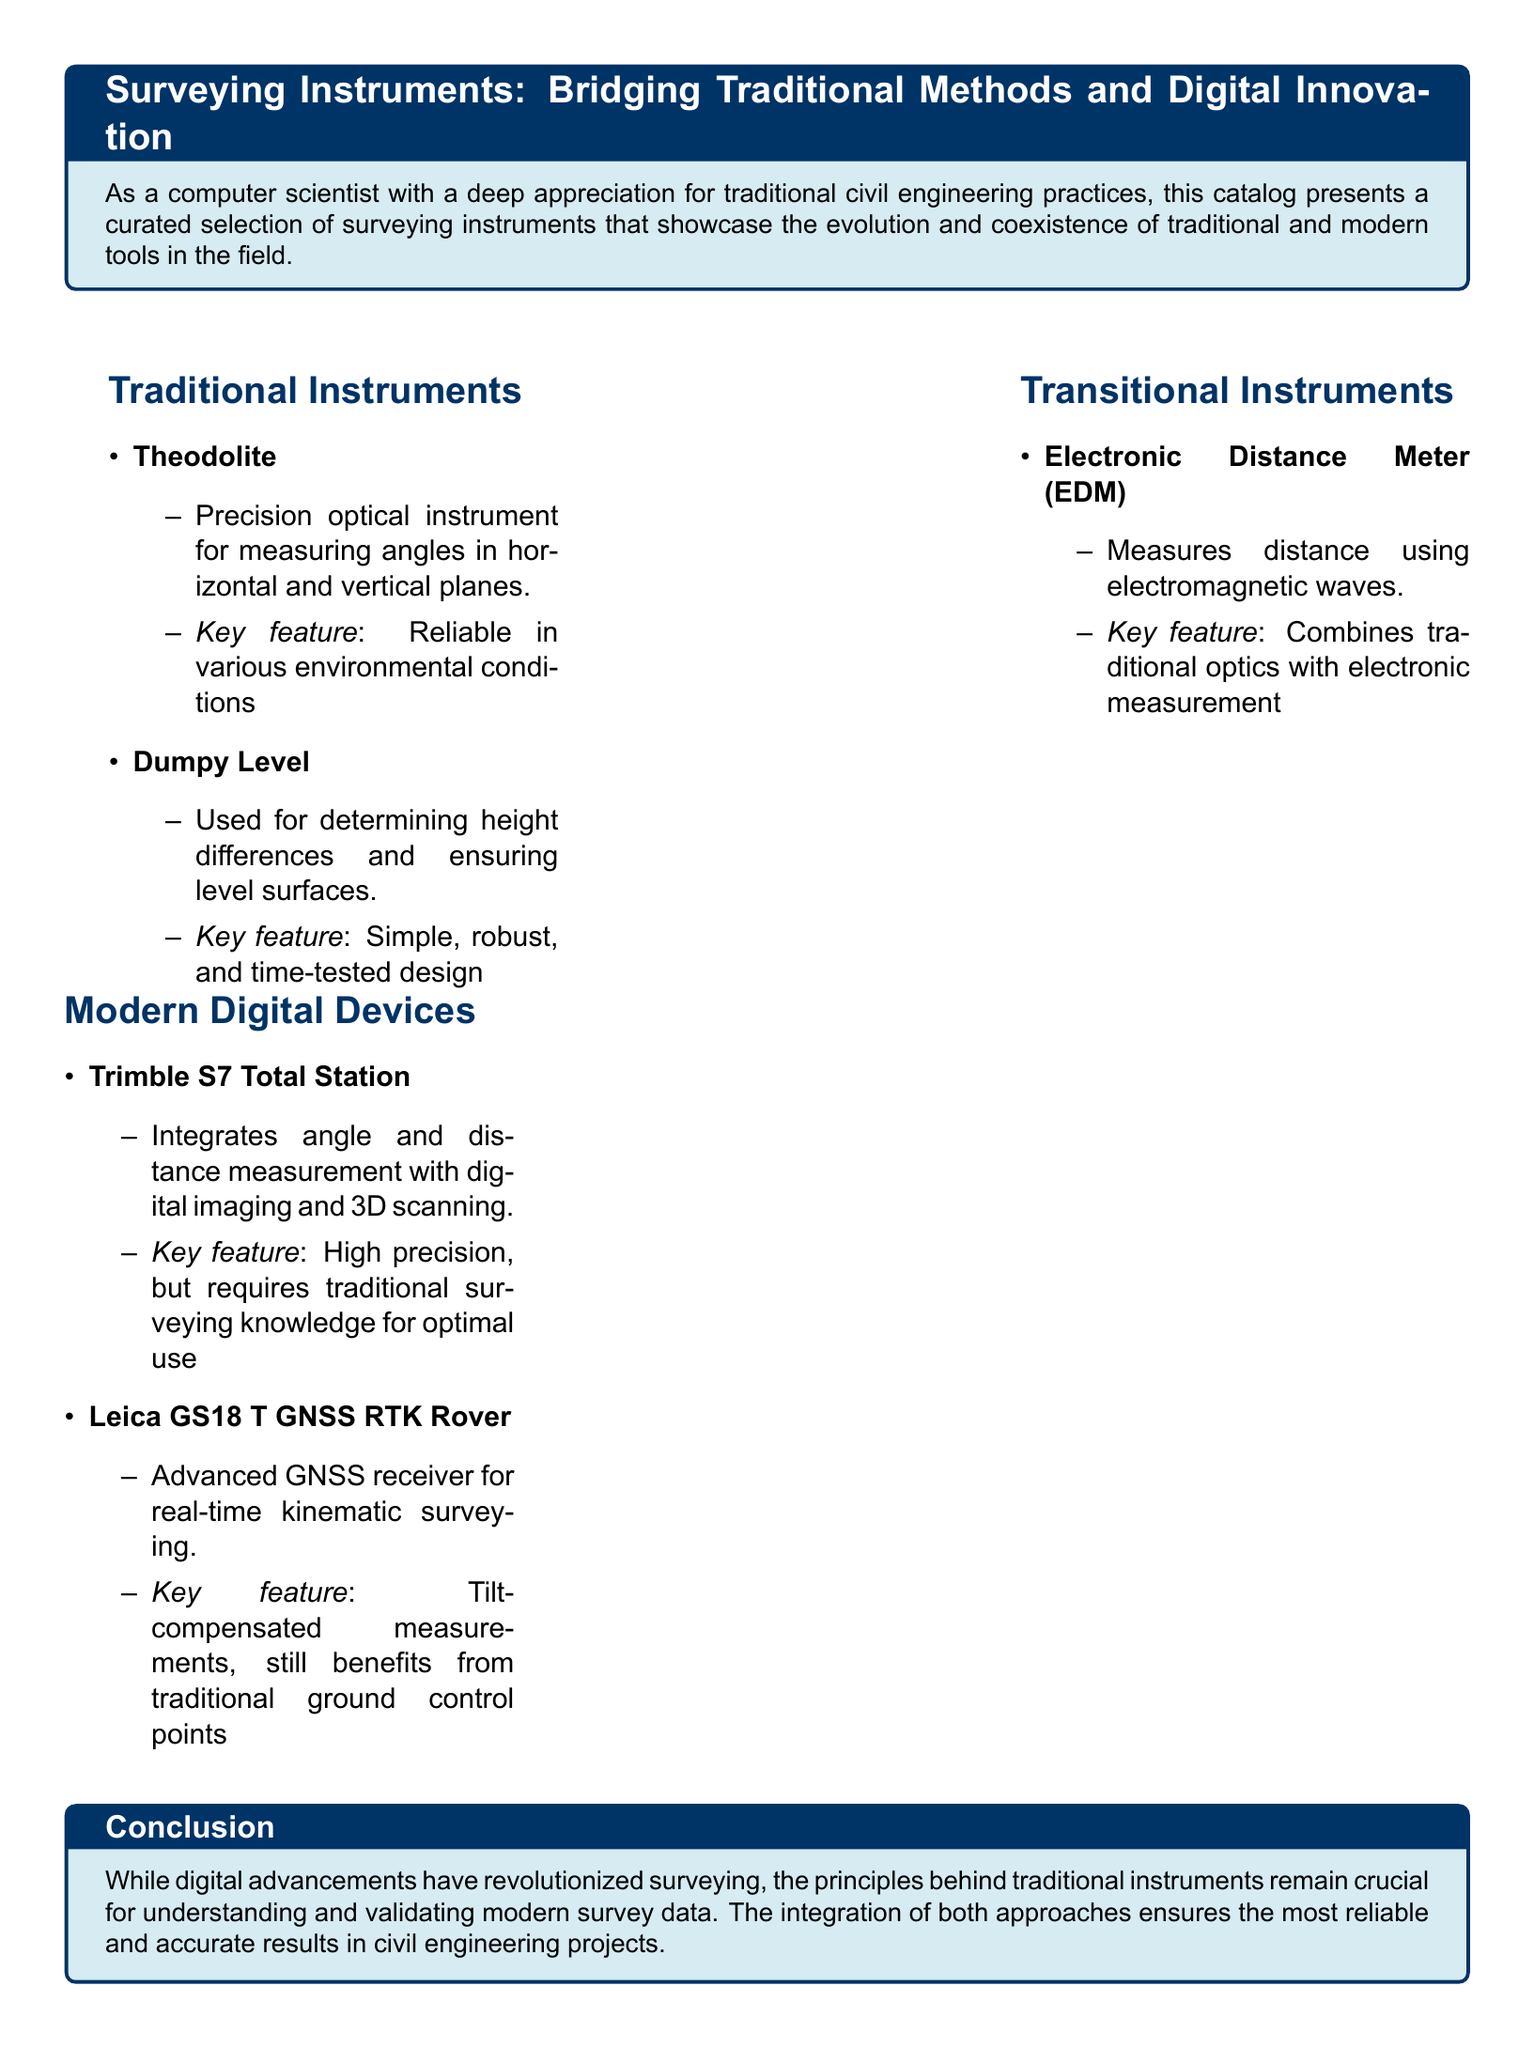What is the purpose of the catalog? The catalog presents a curated selection of surveying instruments that showcase the evolution and coexistence of traditional and modern tools in the field.
Answer: Evolution and coexistence What instrument is used for determining height differences? The Dumpy Level is specifically mentioned in the document as being used for determining height differences and ensuring level surfaces.
Answer: Dumpy Level What key feature is attributed to the Theodolite? The Theodolite is described as having a reliable performance in various environmental conditions.
Answer: Reliable in various environmental conditions Which instrument combines traditional optics with electronic measurement? The Electronic Distance Meter (EDM) is noted for combining traditional optics with electronic measurement.
Answer: Electronic Distance Meter (EDM) What is a key feature of the Trimble S7 Total Station? The key feature of the Trimble S7 Total Station is high precision, but it requires traditional surveying knowledge for optimal use.
Answer: High precision What is the main advantage of the Leica GS18 T GNSS RTK Rover? The Leica GS18 T GNSS RTK Rover provides tilt-compensated measurements, showing a clear advantage in real-time kinematic surveying.
Answer: Tilt-compensated measurements What category do both the Theodolite and Dumpy Level belong to? Both are categorized under Traditional Instruments in the document.
Answer: Traditional Instruments What does the conclusion emphasize regarding modern and traditional surveying methods? The conclusion emphasizes that principles behind traditional instruments remain crucial for understanding and validating modern survey data.
Answer: Crucial for understanding and validating 